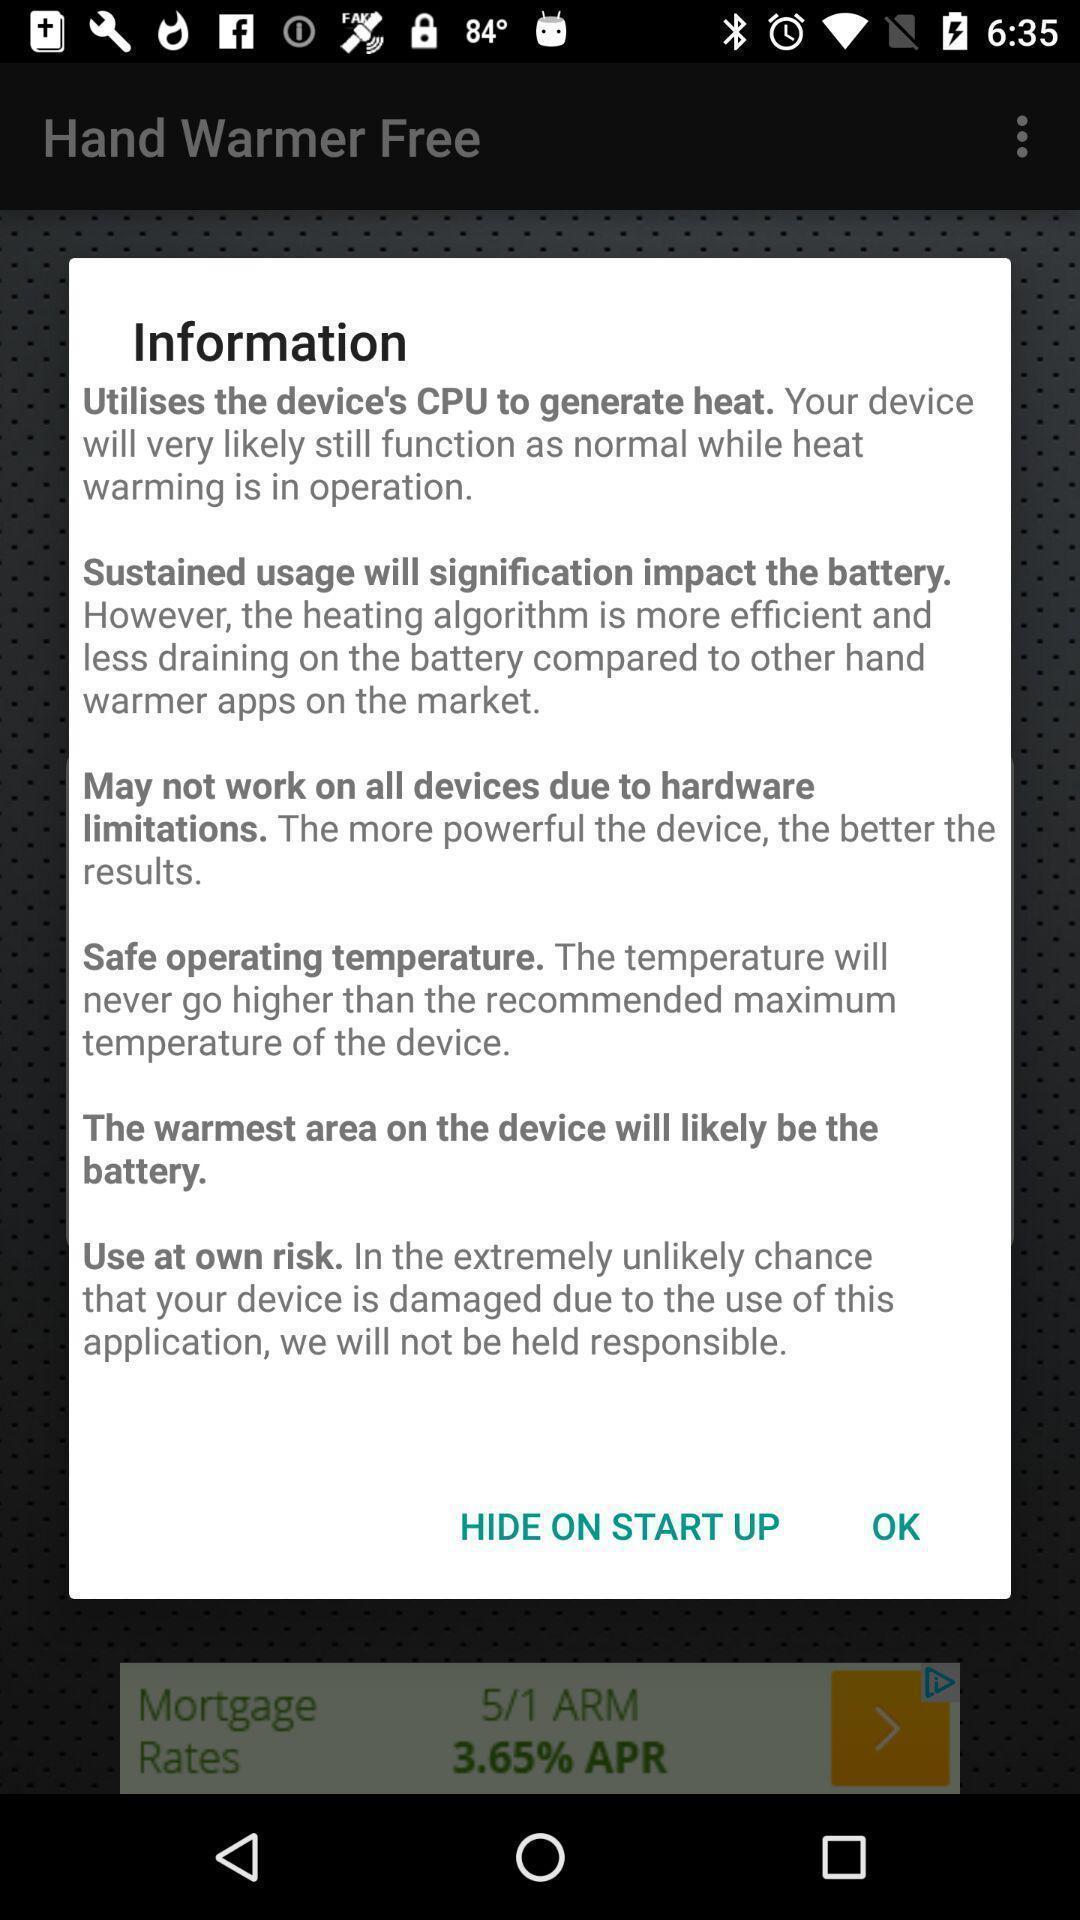Describe the key features of this screenshot. Pop-up showing information page. 